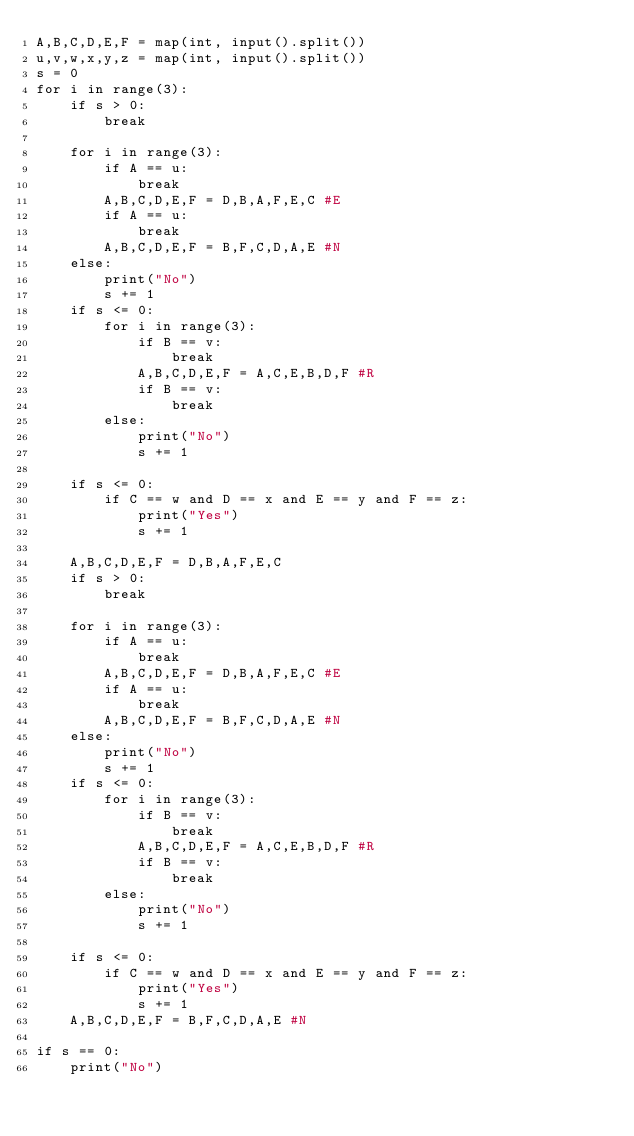Convert code to text. <code><loc_0><loc_0><loc_500><loc_500><_Python_>A,B,C,D,E,F = map(int, input().split())
u,v,w,x,y,z = map(int, input().split())
s = 0
for i in range(3):
    if s > 0:
        break
    
    for i in range(3):
        if A == u:
            break
        A,B,C,D,E,F = D,B,A,F,E,C #E
        if A == u:
            break
        A,B,C,D,E,F = B,F,C,D,A,E #N
    else:
        print("No")
        s += 1
    if s <= 0:    
        for i in range(3):
            if B == v:
                break
            A,B,C,D,E,F = A,C,E,B,D,F #R
            if B == v:
                break
        else:
            print("No")
            s += 1

    if s <= 0:
        if C == w and D == x and E == y and F == z:
            print("Yes")
            s += 1
        
    A,B,C,D,E,F = D,B,A,F,E,C
    if s > 0:
        break
    
    for i in range(3):
        if A == u:
            break
        A,B,C,D,E,F = D,B,A,F,E,C #E
        if A == u:
            break
        A,B,C,D,E,F = B,F,C,D,A,E #N
    else:
        print("No")
        s += 1
    if s <= 0:    
        for i in range(3):
            if B == v:
                break
            A,B,C,D,E,F = A,C,E,B,D,F #R
            if B == v:
                break
        else:
            print("No")
            s += 1

    if s <= 0:
        if C == w and D == x and E == y and F == z:
            print("Yes")
            s += 1
    A,B,C,D,E,F = B,F,C,D,A,E #N
    
if s == 0:
    print("No")</code> 